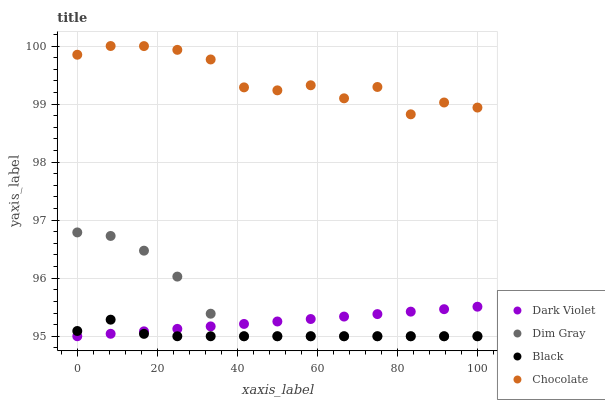Does Black have the minimum area under the curve?
Answer yes or no. Yes. Does Chocolate have the maximum area under the curve?
Answer yes or no. Yes. Does Dark Violet have the minimum area under the curve?
Answer yes or no. No. Does Dark Violet have the maximum area under the curve?
Answer yes or no. No. Is Dark Violet the smoothest?
Answer yes or no. Yes. Is Chocolate the roughest?
Answer yes or no. Yes. Is Black the smoothest?
Answer yes or no. No. Is Black the roughest?
Answer yes or no. No. Does Dim Gray have the lowest value?
Answer yes or no. Yes. Does Chocolate have the lowest value?
Answer yes or no. No. Does Chocolate have the highest value?
Answer yes or no. Yes. Does Dark Violet have the highest value?
Answer yes or no. No. Is Dim Gray less than Chocolate?
Answer yes or no. Yes. Is Chocolate greater than Black?
Answer yes or no. Yes. Does Black intersect Dim Gray?
Answer yes or no. Yes. Is Black less than Dim Gray?
Answer yes or no. No. Is Black greater than Dim Gray?
Answer yes or no. No. Does Dim Gray intersect Chocolate?
Answer yes or no. No. 